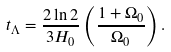<formula> <loc_0><loc_0><loc_500><loc_500>t _ { \Lambda } = \frac { 2 \ln 2 } { 3 H _ { 0 } } \left ( \frac { 1 + \Omega _ { 0 } } { \Omega _ { 0 } } \right ) .</formula> 